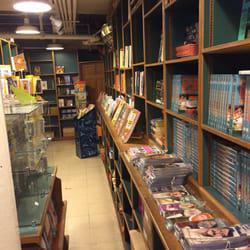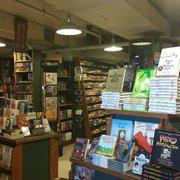The first image is the image on the left, the second image is the image on the right. Examine the images to the left and right. Is the description "The man behind the counter has a beard." accurate? Answer yes or no. No. The first image is the image on the left, the second image is the image on the right. Considering the images on both sides, is "There is at least one person sitting in front of a bookshelf with at least 10 books." valid? Answer yes or no. No. 